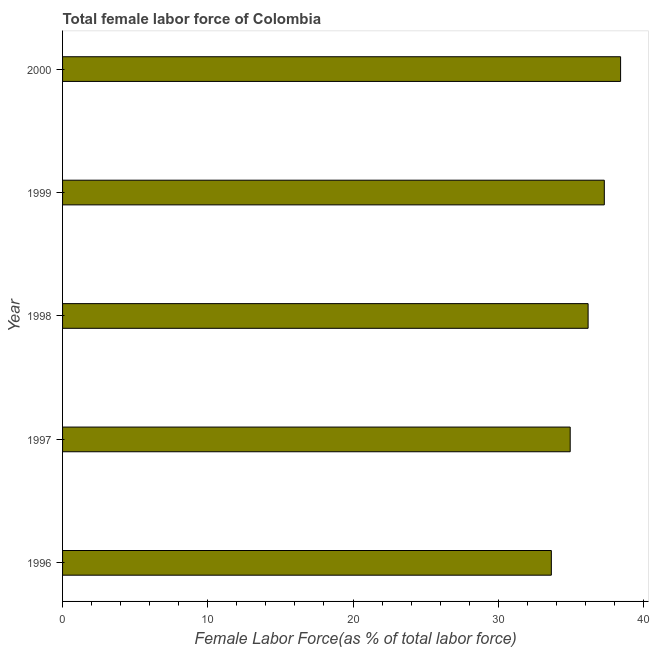Does the graph contain any zero values?
Give a very brief answer. No. What is the title of the graph?
Ensure brevity in your answer.  Total female labor force of Colombia. What is the label or title of the X-axis?
Provide a succinct answer. Female Labor Force(as % of total labor force). What is the total female labor force in 2000?
Ensure brevity in your answer.  38.43. Across all years, what is the maximum total female labor force?
Ensure brevity in your answer.  38.43. Across all years, what is the minimum total female labor force?
Offer a very short reply. 33.66. In which year was the total female labor force maximum?
Offer a terse response. 2000. What is the sum of the total female labor force?
Give a very brief answer. 180.53. What is the difference between the total female labor force in 1997 and 2000?
Offer a very short reply. -3.47. What is the average total female labor force per year?
Provide a short and direct response. 36.11. What is the median total female labor force?
Give a very brief answer. 36.19. Do a majority of the years between 2000 and 1997 (inclusive) have total female labor force greater than 12 %?
Your answer should be very brief. Yes. What is the ratio of the total female labor force in 1996 to that in 2000?
Your answer should be compact. 0.88. Is the total female labor force in 1999 less than that in 2000?
Offer a very short reply. Yes. Is the difference between the total female labor force in 1999 and 2000 greater than the difference between any two years?
Your answer should be very brief. No. What is the difference between the highest and the second highest total female labor force?
Your response must be concise. 1.12. What is the difference between the highest and the lowest total female labor force?
Offer a terse response. 4.77. In how many years, is the total female labor force greater than the average total female labor force taken over all years?
Offer a terse response. 3. Are all the bars in the graph horizontal?
Give a very brief answer. Yes. What is the Female Labor Force(as % of total labor force) of 1996?
Provide a succinct answer. 33.66. What is the Female Labor Force(as % of total labor force) in 1997?
Keep it short and to the point. 34.96. What is the Female Labor Force(as % of total labor force) in 1998?
Your response must be concise. 36.19. What is the Female Labor Force(as % of total labor force) in 1999?
Your answer should be compact. 37.31. What is the Female Labor Force(as % of total labor force) in 2000?
Your answer should be compact. 38.43. What is the difference between the Female Labor Force(as % of total labor force) in 1996 and 1997?
Offer a very short reply. -1.3. What is the difference between the Female Labor Force(as % of total labor force) in 1996 and 1998?
Keep it short and to the point. -2.53. What is the difference between the Female Labor Force(as % of total labor force) in 1996 and 1999?
Ensure brevity in your answer.  -3.65. What is the difference between the Female Labor Force(as % of total labor force) in 1996 and 2000?
Ensure brevity in your answer.  -4.77. What is the difference between the Female Labor Force(as % of total labor force) in 1997 and 1998?
Provide a succinct answer. -1.23. What is the difference between the Female Labor Force(as % of total labor force) in 1997 and 1999?
Your response must be concise. -2.35. What is the difference between the Female Labor Force(as % of total labor force) in 1997 and 2000?
Offer a very short reply. -3.47. What is the difference between the Female Labor Force(as % of total labor force) in 1998 and 1999?
Make the answer very short. -1.12. What is the difference between the Female Labor Force(as % of total labor force) in 1998 and 2000?
Make the answer very short. -2.24. What is the difference between the Female Labor Force(as % of total labor force) in 1999 and 2000?
Ensure brevity in your answer.  -1.12. What is the ratio of the Female Labor Force(as % of total labor force) in 1996 to that in 1998?
Offer a very short reply. 0.93. What is the ratio of the Female Labor Force(as % of total labor force) in 1996 to that in 1999?
Give a very brief answer. 0.9. What is the ratio of the Female Labor Force(as % of total labor force) in 1996 to that in 2000?
Your answer should be very brief. 0.88. What is the ratio of the Female Labor Force(as % of total labor force) in 1997 to that in 1999?
Provide a succinct answer. 0.94. What is the ratio of the Female Labor Force(as % of total labor force) in 1997 to that in 2000?
Keep it short and to the point. 0.91. What is the ratio of the Female Labor Force(as % of total labor force) in 1998 to that in 1999?
Provide a succinct answer. 0.97. What is the ratio of the Female Labor Force(as % of total labor force) in 1998 to that in 2000?
Your response must be concise. 0.94. 